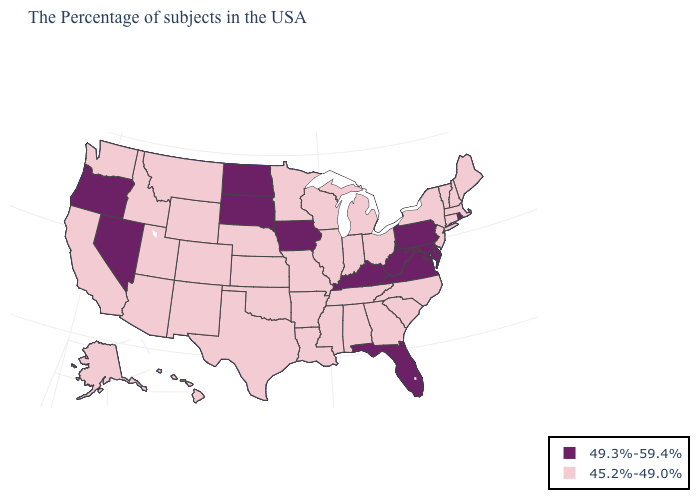Does Tennessee have the lowest value in the USA?
Keep it brief. Yes. Name the states that have a value in the range 45.2%-49.0%?
Answer briefly. Maine, Massachusetts, New Hampshire, Vermont, Connecticut, New York, New Jersey, North Carolina, South Carolina, Ohio, Georgia, Michigan, Indiana, Alabama, Tennessee, Wisconsin, Illinois, Mississippi, Louisiana, Missouri, Arkansas, Minnesota, Kansas, Nebraska, Oklahoma, Texas, Wyoming, Colorado, New Mexico, Utah, Montana, Arizona, Idaho, California, Washington, Alaska, Hawaii. What is the value of Arizona?
Keep it brief. 45.2%-49.0%. Name the states that have a value in the range 49.3%-59.4%?
Answer briefly. Rhode Island, Delaware, Maryland, Pennsylvania, Virginia, West Virginia, Florida, Kentucky, Iowa, South Dakota, North Dakota, Nevada, Oregon. What is the lowest value in states that border Delaware?
Quick response, please. 45.2%-49.0%. Name the states that have a value in the range 49.3%-59.4%?
Keep it brief. Rhode Island, Delaware, Maryland, Pennsylvania, Virginia, West Virginia, Florida, Kentucky, Iowa, South Dakota, North Dakota, Nevada, Oregon. Name the states that have a value in the range 45.2%-49.0%?
Short answer required. Maine, Massachusetts, New Hampshire, Vermont, Connecticut, New York, New Jersey, North Carolina, South Carolina, Ohio, Georgia, Michigan, Indiana, Alabama, Tennessee, Wisconsin, Illinois, Mississippi, Louisiana, Missouri, Arkansas, Minnesota, Kansas, Nebraska, Oklahoma, Texas, Wyoming, Colorado, New Mexico, Utah, Montana, Arizona, Idaho, California, Washington, Alaska, Hawaii. What is the value of Nebraska?
Be succinct. 45.2%-49.0%. What is the value of New Hampshire?
Be succinct. 45.2%-49.0%. Name the states that have a value in the range 49.3%-59.4%?
Keep it brief. Rhode Island, Delaware, Maryland, Pennsylvania, Virginia, West Virginia, Florida, Kentucky, Iowa, South Dakota, North Dakota, Nevada, Oregon. What is the value of California?
Answer briefly. 45.2%-49.0%. What is the value of New Hampshire?
Give a very brief answer. 45.2%-49.0%. What is the value of Nebraska?
Answer briefly. 45.2%-49.0%. Does Kentucky have the same value as Colorado?
Concise answer only. No. What is the lowest value in states that border Massachusetts?
Quick response, please. 45.2%-49.0%. 